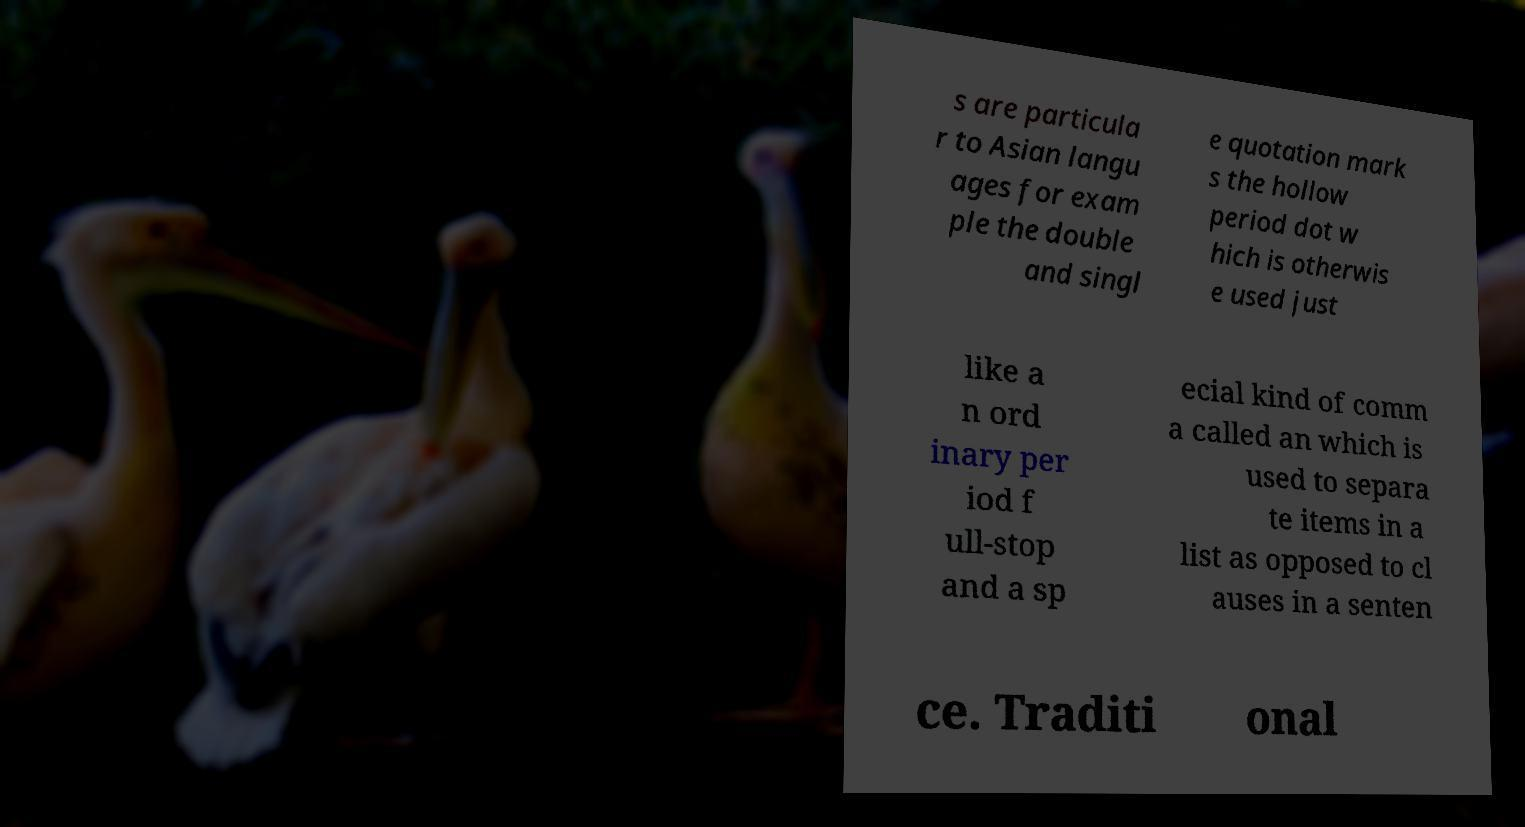Please identify and transcribe the text found in this image. s are particula r to Asian langu ages for exam ple the double and singl e quotation mark s the hollow period dot w hich is otherwis e used just like a n ord inary per iod f ull-stop and a sp ecial kind of comm a called an which is used to separa te items in a list as opposed to cl auses in a senten ce. Traditi onal 